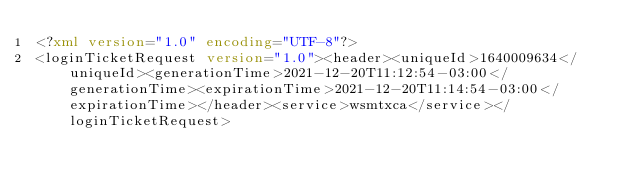<code> <loc_0><loc_0><loc_500><loc_500><_XML_><?xml version="1.0" encoding="UTF-8"?>
<loginTicketRequest version="1.0"><header><uniqueId>1640009634</uniqueId><generationTime>2021-12-20T11:12:54-03:00</generationTime><expirationTime>2021-12-20T11:14:54-03:00</expirationTime></header><service>wsmtxca</service></loginTicketRequest>
</code> 